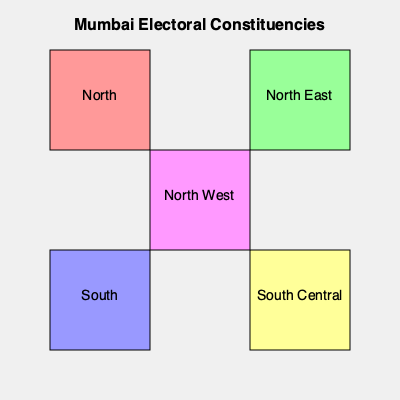Based on the map of Mumbai's electoral constituencies, which constituency is located in the center of the map? To answer this question, we need to analyze the simple map of Mumbai's electoral constituencies:

1. The map shows five constituencies: North, North East, South, South Central, and North West.

2. The constituencies are represented by colored rectangles arranged in a grid-like pattern.

3. The North constituency is in the top-left corner.
4. The North East constituency is in the top-right corner.
5. The South constituency is in the bottom-left corner.
6. The South Central constituency is in the bottom-right corner.

7. The North West constituency is positioned in the center of the map, surrounded by the other four constituencies.

Therefore, the constituency located in the center of the map is North West.
Answer: North West 